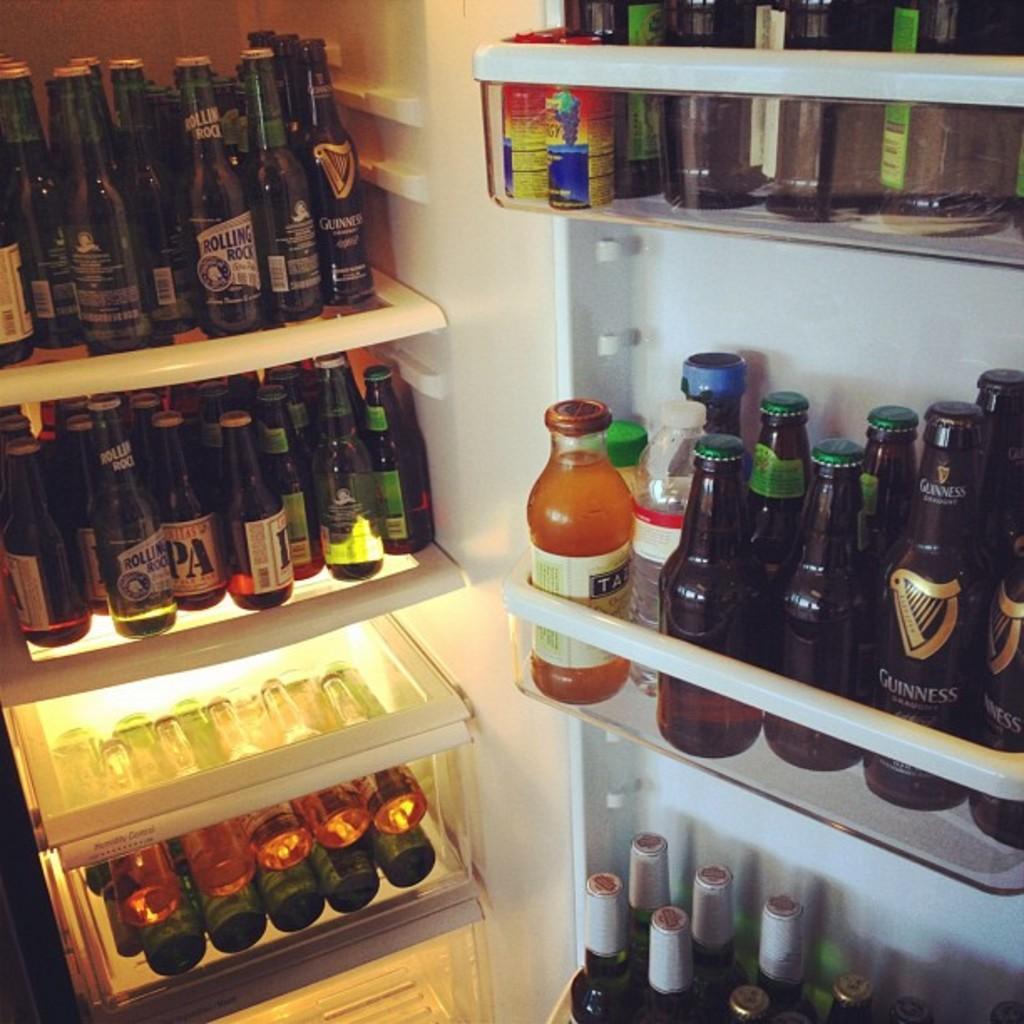Can you describe this image briefly? This is a picture of a fridge in which there are some bottles placed in the different shelves. 